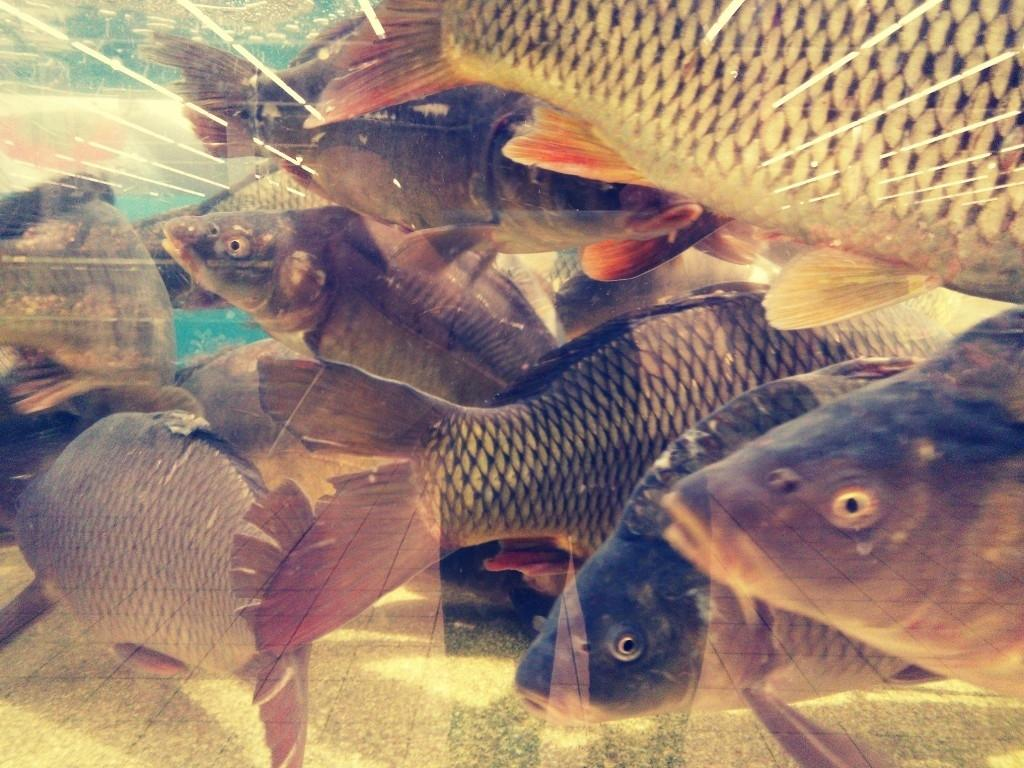What type of animals can be seen in the image? There are fishes in the image. Where are the fishes located? The fishes are in the water. What type of books can be seen on the throne in the image? There is no throne or books present in the image; it features fishes in the water. 